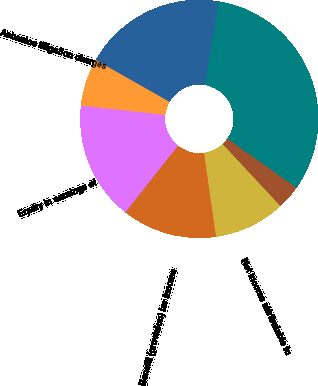Convert chart. <chart><loc_0><loc_0><loc_500><loc_500><pie_chart><fcel>Net sales<fcel>Gross margin<fcel>Asbestos litigation charges<fcel>Equity in earnings of<fcel>Benefit (provision) for income<fcel>Net income attributable to<fcel>Basic earnings per common<fcel>Diluted earnings per common<nl><fcel>32.26%<fcel>19.35%<fcel>6.45%<fcel>16.13%<fcel>12.9%<fcel>9.68%<fcel>0.0%<fcel>3.23%<nl></chart> 